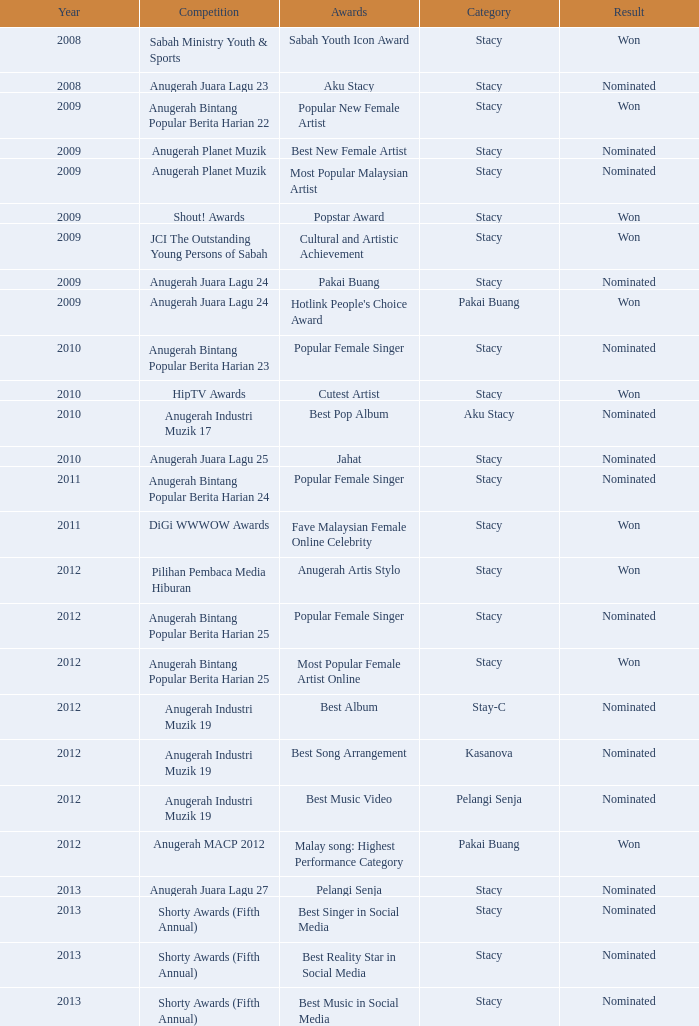What award was in the year after 2009 with a competition of Digi Wwwow Awards? Fave Malaysian Female Online Celebrity. 